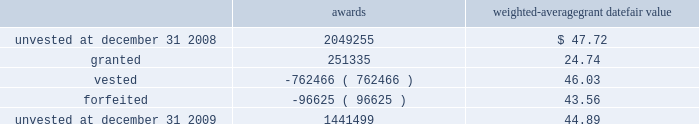Marathon oil corporation notes to consolidated financial statements restricted stock awards the following is a summary of restricted stock award activity .
Awards weighted-average grant date fair value .
The vesting date fair value of restricted stock awards which vested during 2009 , 2008 and 2007 was $ 24 million , $ 38 million and $ 29 million .
The weighted average grant date fair value of restricted stock awards was $ 44.89 , $ 47.72 , and $ 39.87 for awards unvested at december 31 , 2009 , 2008 and 2007 .
As of december 31 , 2009 , there was $ 43 million of unrecognized compensation cost related to restricted stock awards which is expected to be recognized over a weighted average period of 1.6 years .
Stock-based performance awards all stock-based performance awards have either vested or been forfeited .
The vesting date fair value of stock- based performance awards which vested during 2007 was $ 38 .
24 .
Stockholders 2019 equity in each year , 2009 and 2008 , we issued 2 million in common stock upon the redemption of the exchangeable shares described below in addition to treasury shares issued for employee stock-based awards .
The board of directors has authorized the repurchase of up to $ 5 billion of marathon common stock .
Purchases under the program may be in either open market transactions , including block purchases , or in privately negotiated transactions .
We will use cash on hand , cash generated from operations , proceeds from potential asset sales or cash from available borrowings to acquire shares .
This program may be changed based upon our financial condition or changes in market conditions and is subject to termination prior to completion .
The repurchase program does not include specific price targets or timetables .
As of december 31 , 2009 , we have acquired 66 million common shares at a cost of $ 2922 million under the program .
No shares have been acquired since august 2008 .
Securities exchangeable into marathon common stock 2013 as discussed in note 6 , we acquired all of the outstanding shares of western on october 18 , 2007 .
The western shareholders who were canadian residents received , at their election , cash , marathon common stock , securities exchangeable into marathon common stock ( the 201cexchangeable shares 201d ) or a combination thereof .
The western shareholders elected to receive 5 million exchangeable shares as part of the acquisition consideration .
The exchangeable shares are shares of an indirect canadian subsidiary of marathon and , at the acquisition date , were exchangeable on a one-for-one basis into marathon common stock .
Subsequent to the acquisition , the exchange ratio is adjusted to reflect cash dividends , if any , paid on marathon common stock and cash dividends , if any , paid on the exchangeable shares .
The exchange ratio at december 31 , 2009 , was 1.06109 common shares for each exchangeable share .
The exchangeable shares are exchangeable at the option of the holder at any time and are automatically redeemable on october 18 , 2011 .
Holders of exchangeable shares are entitled to instruct a trustee to vote ( or obtain a proxy from the trustee to vote directly ) on all matters submitted to the holders of marathon common stock .
The number of votes to which each holder is entitled is equal to the whole number of shares of marathon common stock into which such holder 2019s exchangeable shares would be exchangeable based on the exchange ratio in effect on the record date for the vote .
The voting right is attached to voting preferred shares of marathon that were issued to a trustee in an amount .
As of december 31 , 2009 , what was the average cost per share of the acquired 66 million common shares under the program? 
Computations: (2922 / 66)
Answer: 44.27273. 